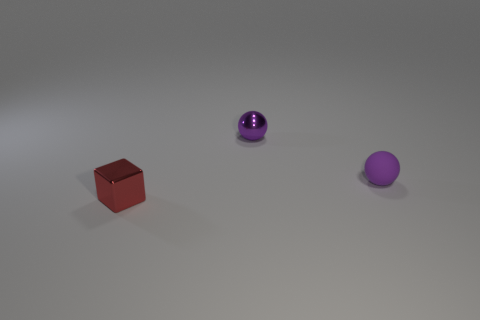How many purple spheres must be subtracted to get 1 purple spheres? 1 Add 1 tiny purple rubber objects. How many objects exist? 4 Add 1 purple objects. How many purple objects exist? 3 Subtract 0 green spheres. How many objects are left? 3 Subtract all spheres. How many objects are left? 1 Subtract 1 balls. How many balls are left? 1 Subtract all yellow spheres. Subtract all cyan cubes. How many spheres are left? 2 Subtract all brown cylinders. How many purple blocks are left? 0 Subtract all cyan metallic balls. Subtract all tiny shiny cubes. How many objects are left? 2 Add 1 small spheres. How many small spheres are left? 3 